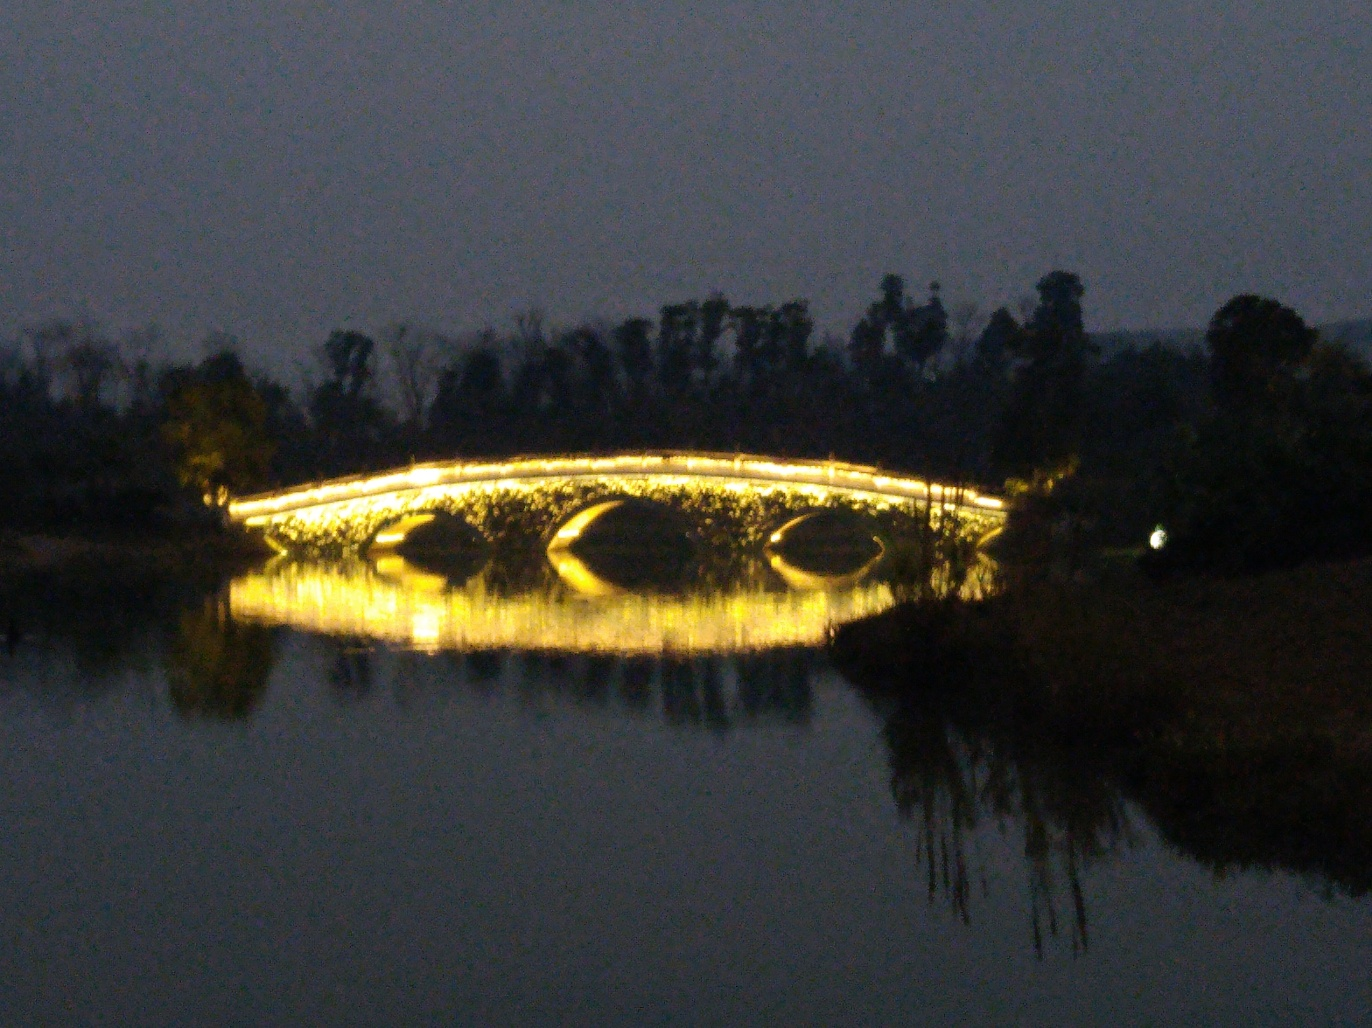What time of day was this photo taken, and what mood does it evoke? The photo appears to be taken during nighttime, highlighted by the artificial lights on the bridge and the deep blue of the sky. It evokes a mood of tranquility and peacefulness with the still waters creating a perfect mirror image of the bridge. 